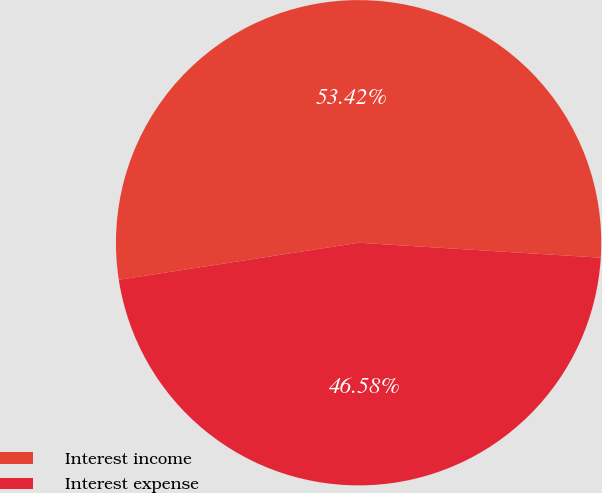<chart> <loc_0><loc_0><loc_500><loc_500><pie_chart><fcel>Interest income<fcel>Interest expense<nl><fcel>53.42%<fcel>46.58%<nl></chart> 